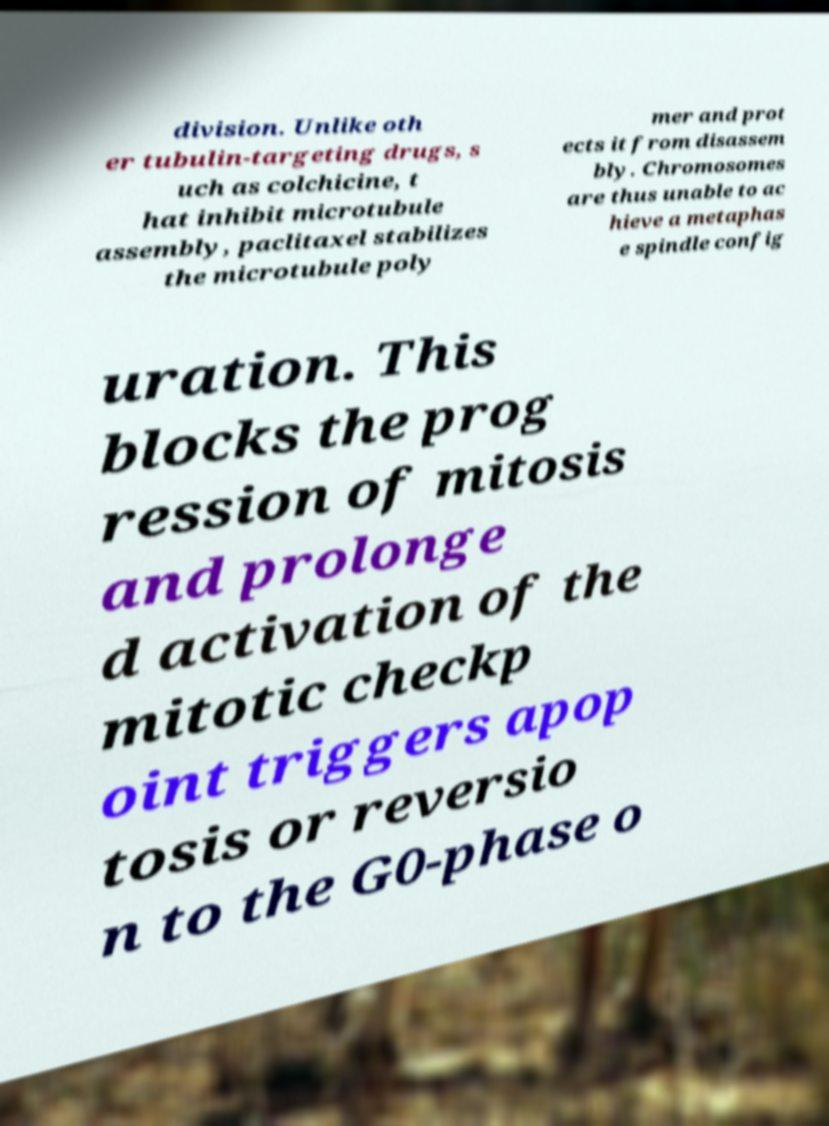For documentation purposes, I need the text within this image transcribed. Could you provide that? division. Unlike oth er tubulin-targeting drugs, s uch as colchicine, t hat inhibit microtubule assembly, paclitaxel stabilizes the microtubule poly mer and prot ects it from disassem bly. Chromosomes are thus unable to ac hieve a metaphas e spindle config uration. This blocks the prog ression of mitosis and prolonge d activation of the mitotic checkp oint triggers apop tosis or reversio n to the G0-phase o 